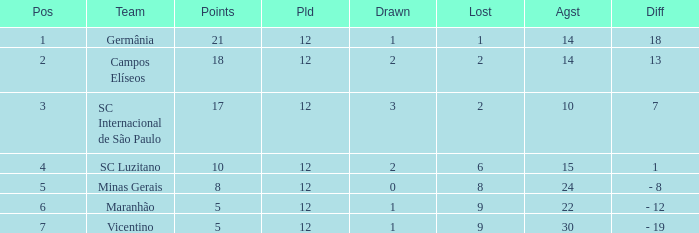What difference has a points greater than 10, and a drawn less than 2? 18.0. 